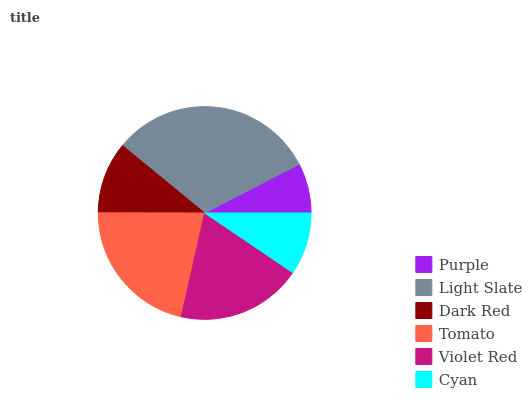Is Purple the minimum?
Answer yes or no. Yes. Is Light Slate the maximum?
Answer yes or no. Yes. Is Dark Red the minimum?
Answer yes or no. No. Is Dark Red the maximum?
Answer yes or no. No. Is Light Slate greater than Dark Red?
Answer yes or no. Yes. Is Dark Red less than Light Slate?
Answer yes or no. Yes. Is Dark Red greater than Light Slate?
Answer yes or no. No. Is Light Slate less than Dark Red?
Answer yes or no. No. Is Violet Red the high median?
Answer yes or no. Yes. Is Dark Red the low median?
Answer yes or no. Yes. Is Cyan the high median?
Answer yes or no. No. Is Violet Red the low median?
Answer yes or no. No. 